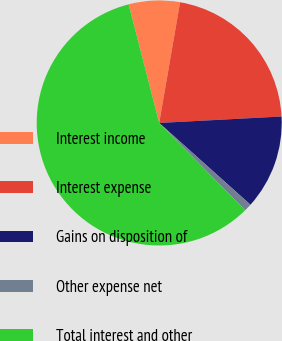<chart> <loc_0><loc_0><loc_500><loc_500><pie_chart><fcel>Interest income<fcel>Interest expense<fcel>Gains on disposition of<fcel>Other expense net<fcel>Total interest and other<nl><fcel>6.74%<fcel>21.43%<fcel>12.47%<fcel>1.0%<fcel>58.35%<nl></chart> 